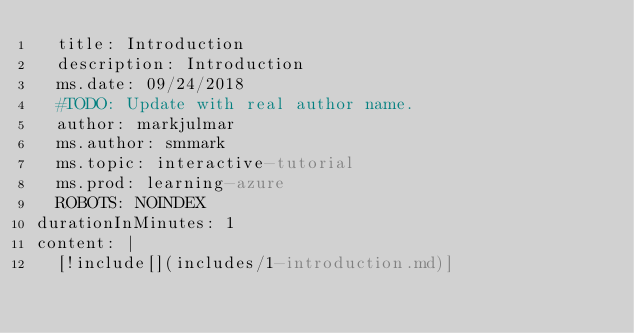<code> <loc_0><loc_0><loc_500><loc_500><_YAML_>  title: Introduction
  description: Introduction
  ms.date: 09/24/2018
  #TODO: Update with real author name.
  author: markjulmar
  ms.author: smmark
  ms.topic: interactive-tutorial
  ms.prod: learning-azure
  ROBOTS: NOINDEX
durationInMinutes: 1
content: |
  [!include[](includes/1-introduction.md)]</code> 